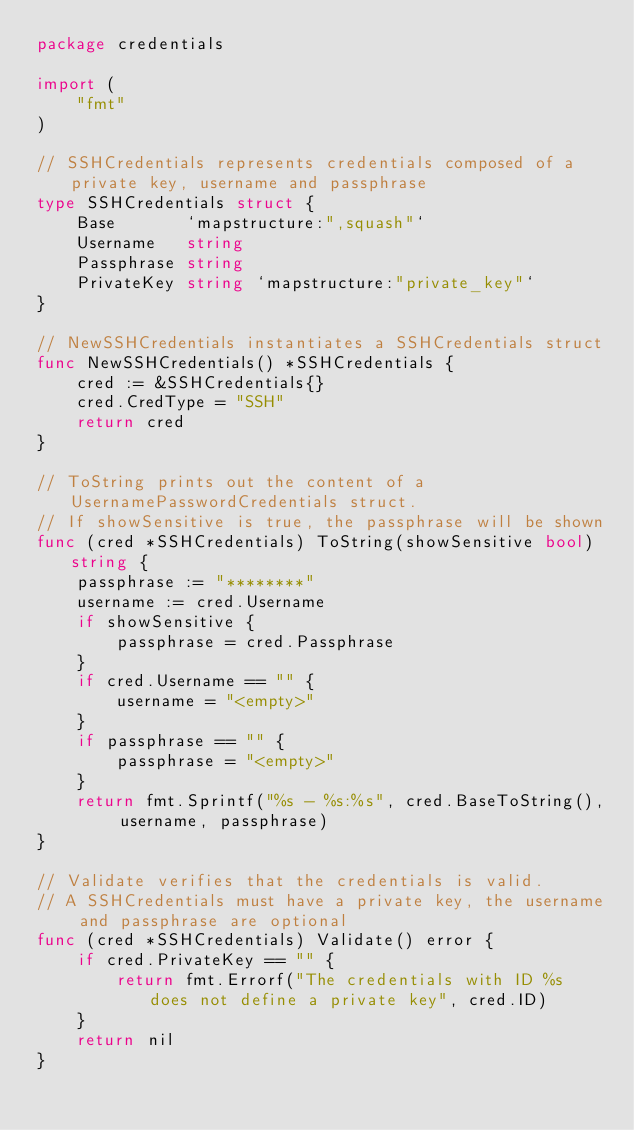Convert code to text. <code><loc_0><loc_0><loc_500><loc_500><_Go_>package credentials

import (
	"fmt"
)

// SSHCredentials represents credentials composed of a private key, username and passphrase
type SSHCredentials struct {
	Base       `mapstructure:",squash"`
	Username   string
	Passphrase string
	PrivateKey string `mapstructure:"private_key"`
}

// NewSSHCredentials instantiates a SSHCredentials struct
func NewSSHCredentials() *SSHCredentials {
	cred := &SSHCredentials{}
	cred.CredType = "SSH"
	return cred
}

// ToString prints out the content of a UsernamePasswordCredentials struct.
// If showSensitive is true, the passphrase will be shown
func (cred *SSHCredentials) ToString(showSensitive bool) string {
	passphrase := "********"
	username := cred.Username
	if showSensitive {
		passphrase = cred.Passphrase
	}
	if cred.Username == "" {
		username = "<empty>"
	}
	if passphrase == "" {
		passphrase = "<empty>"
	}
	return fmt.Sprintf("%s - %s:%s", cred.BaseToString(), username, passphrase)
}

// Validate verifies that the credentials is valid.
// A SSHCredentials must have a private key, the username and passphrase are optional
func (cred *SSHCredentials) Validate() error {
	if cred.PrivateKey == "" {
		return fmt.Errorf("The credentials with ID %s does not define a private key", cred.ID)
	}
	return nil
}
</code> 